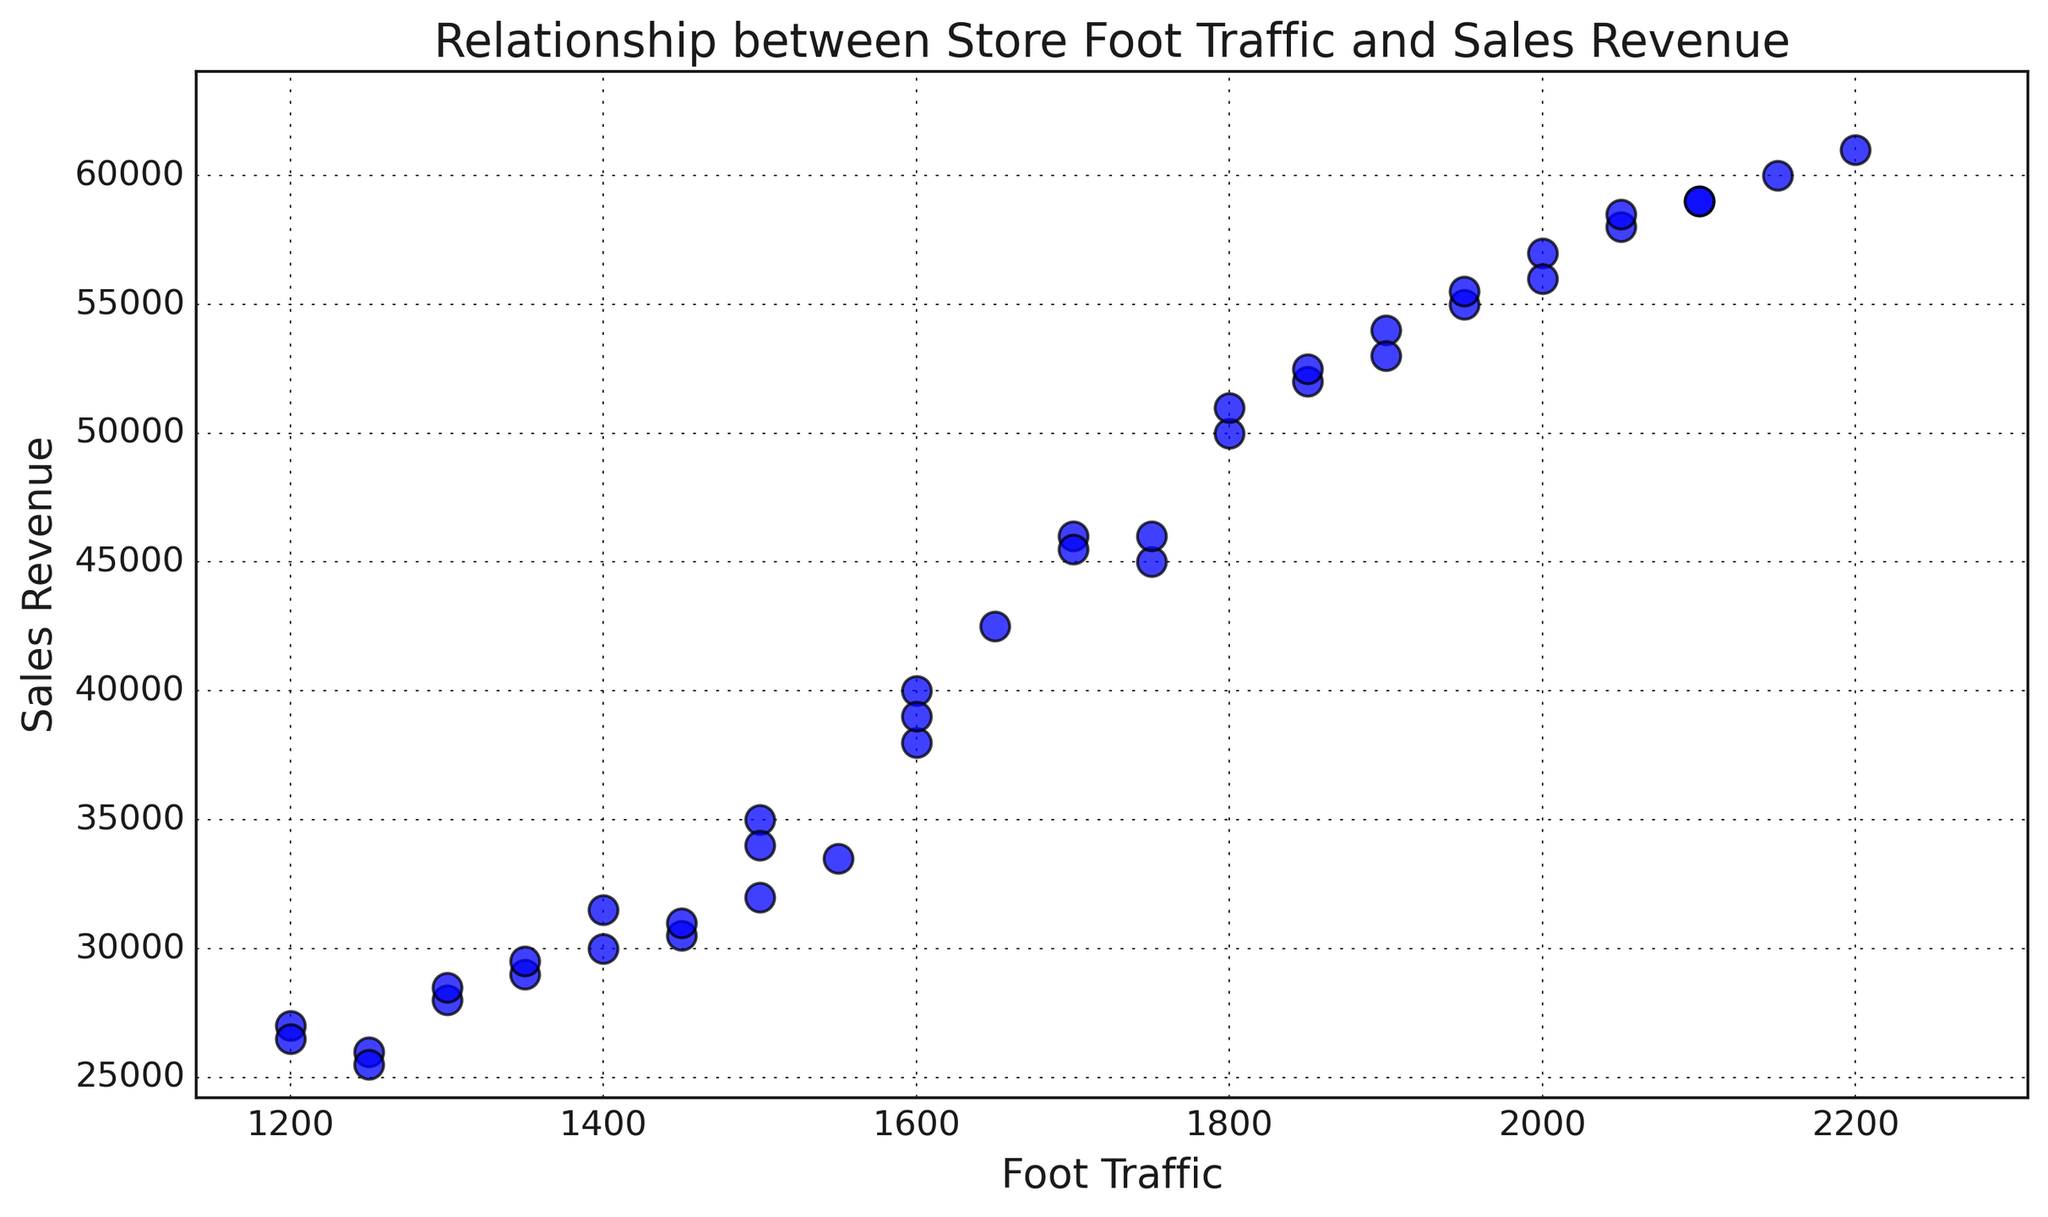What's the average sales revenue for stores with foot traffic between 1500 and 2000? First, identify the stores with foot traffic between 1500 and 2000 by looking at the x-axis. Then, locate their corresponding sales revenue on the y-axis. Calculate the average by adding these sales revenues and dividing by the number of such stores.
Answer: 43800 Which store has the highest sales revenue, and what is its foot traffic? Identify the data point that is highest on the y-axis (sales revenue). Then, look at its corresponding value on the x-axis (foot traffic). In this case, the highest sales revenue data point is at $61000.
Answer: Store 11, 2200 Is there a direct relationship between foot traffic and sales revenue? Evaluate the trend in the scatter plot by observing if higher foot traffic generally corresponds to higher sales revenue. The overall pattern on the plot suggests that as foot traffic increases, sales revenue also tends to increase, indicating a positive relationship.
Answer: Yes, positive relationship What is the difference in sales revenue between the stores with the lowest and highest foot traffic? Identify the lowest and highest foot traffic from the x-axis, then find their respective sales revenue values on the y-axis. Subtract the lower sales revenue from the higher sales revenue.
Answer: 35500 (61000 - 25500) How many stores have a sales revenue above $50000? Count the number of data points above the $50000 mark on the y-axis. Each data point represents a store.
Answer: 11 What is the median foot traffic value for the data set? Arrange all foot traffic values in ascending order and find the middle value. If there is an even number of values, calculate the average of the two middle values. The median foot traffic is the value that separates the higher half and the lower half of the foot traffic data.
Answer: 1650 Which store has the highest foot traffic but the lowest sales revenue above $50000? Scan for the highest point on the x-axis (foot traffic) and then check the y-axis values that are just above $50000. The highest foot traffic in these higher sales revenue values is likely lower on the y-axis but above $50000.
Answer: Store 21 Is there any outlier in terms of sales revenue significantly deviating from the trend? Look for a data point that is far separated from the cluster of other points, especially if it does not follow the general increasing trend. In this plot, an outlier would be a store whose sales revenue is much higher or lower than what's expected for its foot traffic.
Answer: No apparent outlier Which stores have a foot traffic below 1300, and what's their average sales revenue? Identify the stores with less than 1300 foot traffic on the x-axis, find the y-axis values for those stores, sum up those sales revenue values, and divide by the number of such stores to get the average.
Answer: Store 3 and 24, Average = 26750 